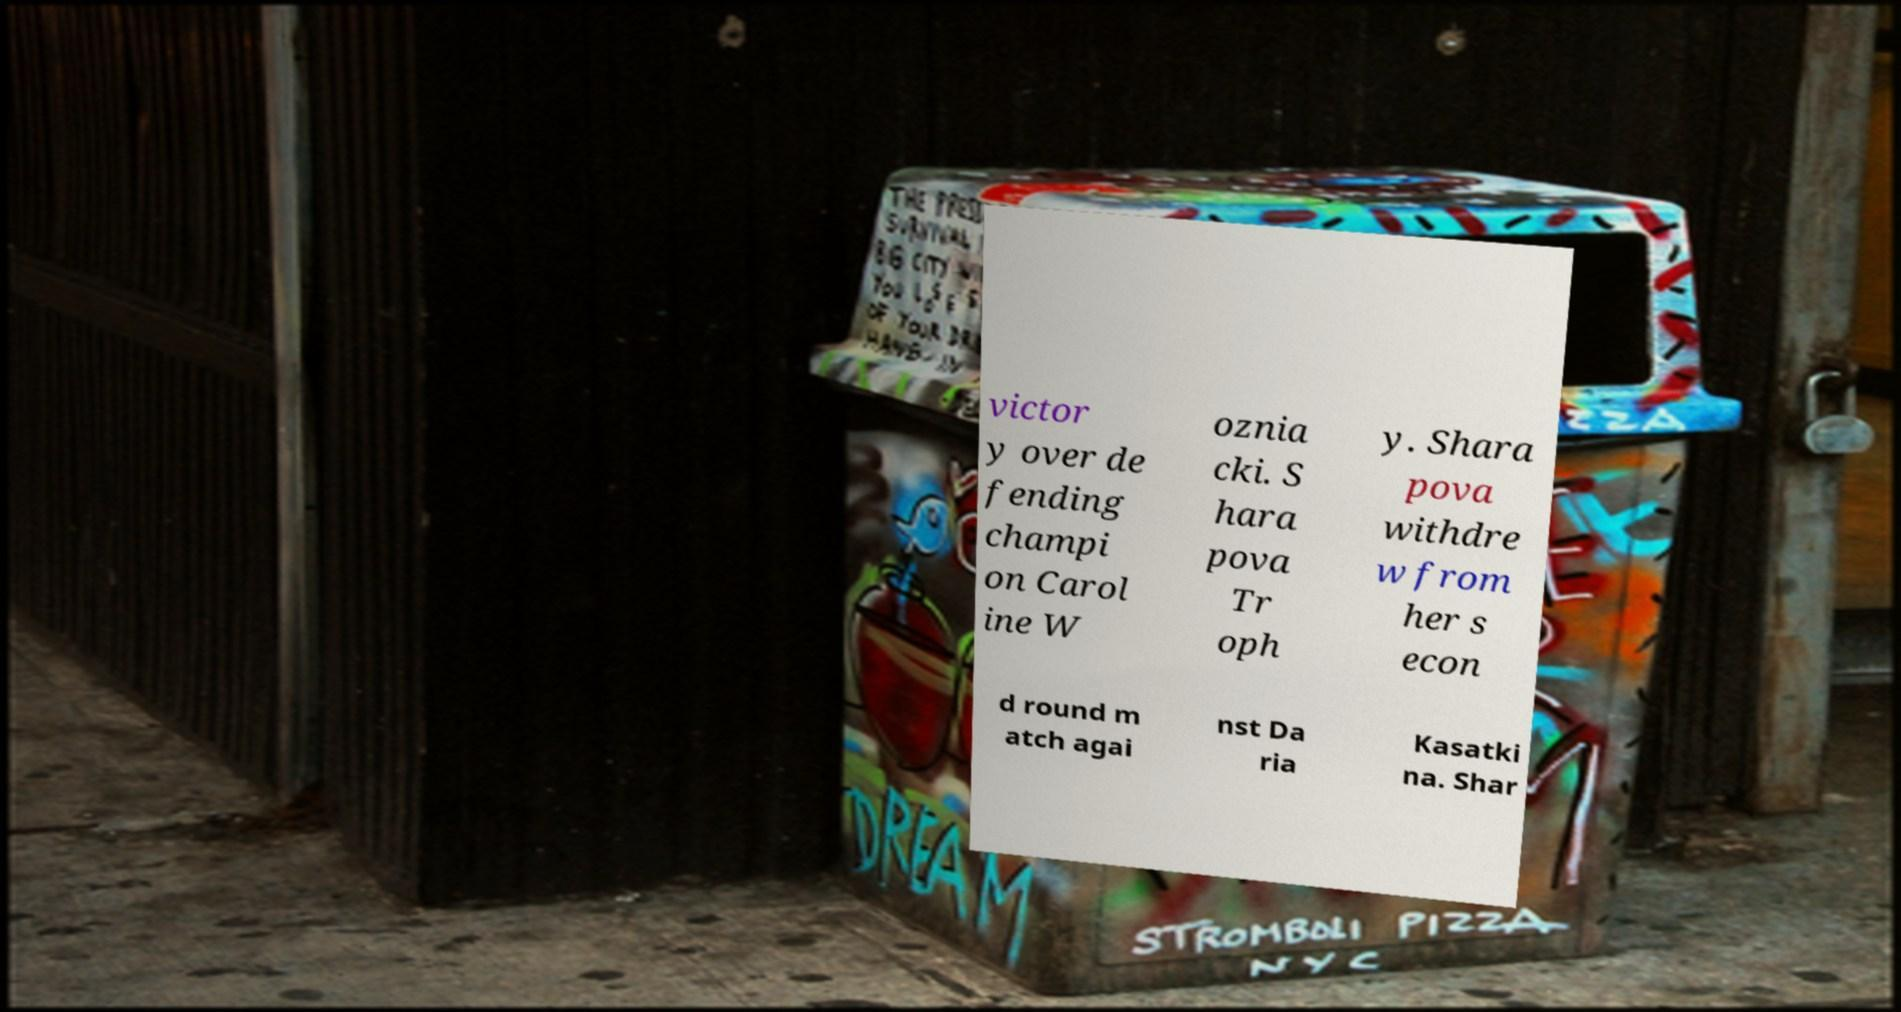Can you read and provide the text displayed in the image?This photo seems to have some interesting text. Can you extract and type it out for me? victor y over de fending champi on Carol ine W oznia cki. S hara pova Tr oph y. Shara pova withdre w from her s econ d round m atch agai nst Da ria Kasatki na. Shar 